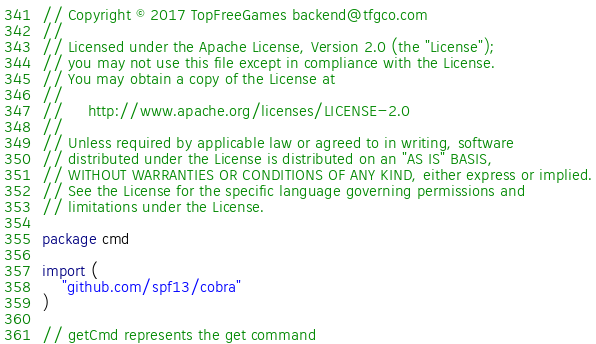<code> <loc_0><loc_0><loc_500><loc_500><_Go_>// Copyright © 2017 TopFreeGames backend@tfgco.com
//
// Licensed under the Apache License, Version 2.0 (the "License");
// you may not use this file except in compliance with the License.
// You may obtain a copy of the License at
//
//     http://www.apache.org/licenses/LICENSE-2.0
//
// Unless required by applicable law or agreed to in writing, software
// distributed under the License is distributed on an "AS IS" BASIS,
// WITHOUT WARRANTIES OR CONDITIONS OF ANY KIND, either express or implied.
// See the License for the specific language governing permissions and
// limitations under the License.

package cmd

import (
	"github.com/spf13/cobra"
)

// getCmd represents the get command</code> 